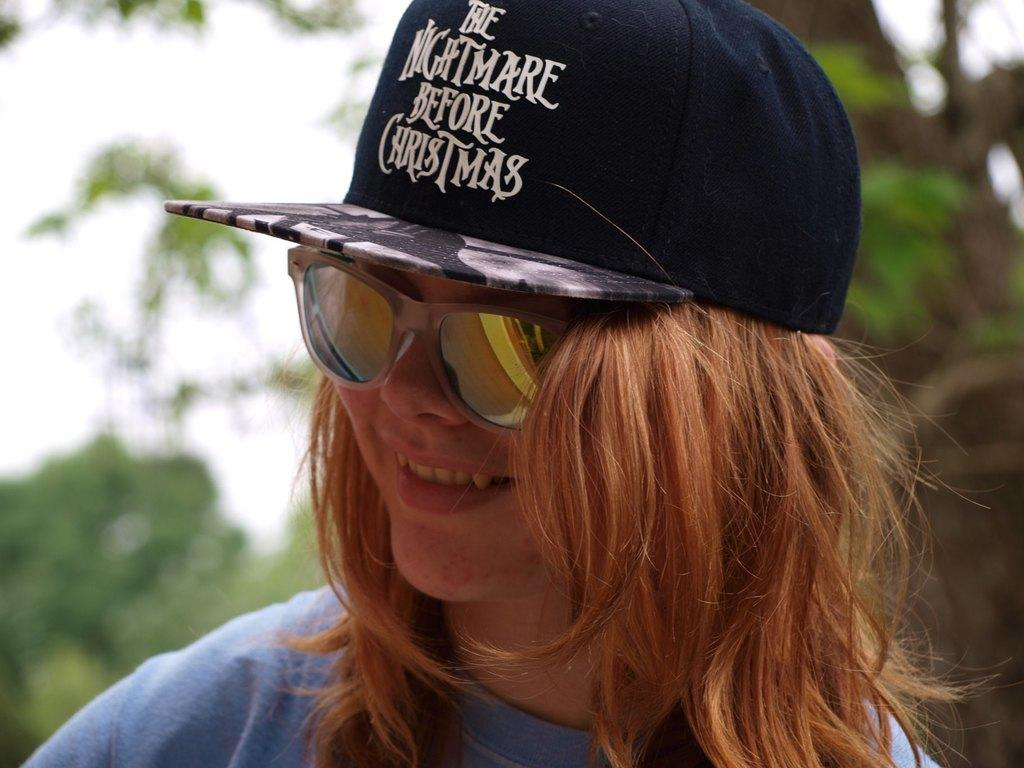Who is the main subject in the image? There is a girl in the image. What is the girl wearing on her head? The girl is wearing a black cap. What type of eyewear is the girl wearing? The girl is wearing sunglasses. Where is the girl positioned in the image? The girl is standing in the front of the image. What is the girl's facial expression? The girl is smiling. In which direction is the girl looking? The girl is looking to the left side. Can you describe the background of the image? There is a blurred background in the image, and trees are visible in the background. What type of produce can be seen in the girl's hand in the image? There is no produce visible in the girl's hand in the image. What kind of owl is perched on the girl's shoulder in the image? There is no owl present in the image. 